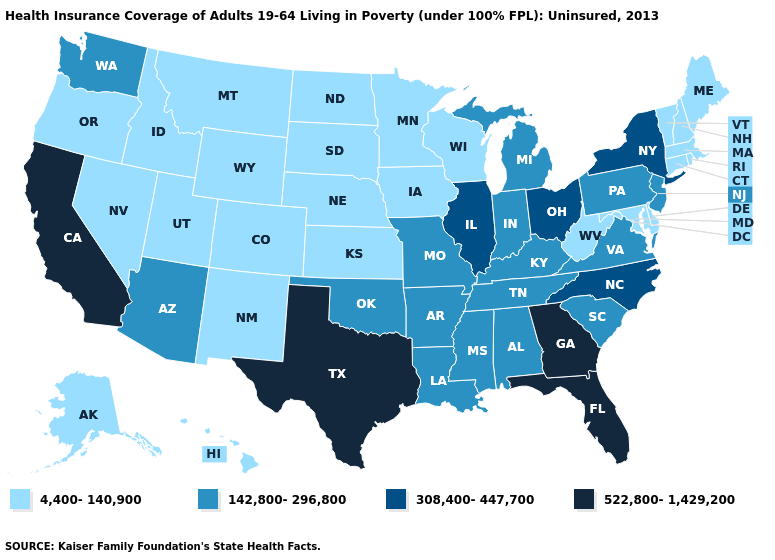What is the value of Vermont?
Concise answer only. 4,400-140,900. Name the states that have a value in the range 308,400-447,700?
Quick response, please. Illinois, New York, North Carolina, Ohio. Among the states that border Utah , which have the lowest value?
Concise answer only. Colorado, Idaho, Nevada, New Mexico, Wyoming. Does Georgia have the highest value in the USA?
Short answer required. Yes. What is the highest value in states that border South Dakota?
Short answer required. 4,400-140,900. Name the states that have a value in the range 522,800-1,429,200?
Quick response, please. California, Florida, Georgia, Texas. What is the lowest value in the USA?
Answer briefly. 4,400-140,900. Does Illinois have the same value as New Jersey?
Write a very short answer. No. Does Utah have the lowest value in the West?
Keep it brief. Yes. Does California have the highest value in the USA?
Give a very brief answer. Yes. How many symbols are there in the legend?
Concise answer only. 4. What is the value of Montana?
Answer briefly. 4,400-140,900. Which states have the lowest value in the USA?
Write a very short answer. Alaska, Colorado, Connecticut, Delaware, Hawaii, Idaho, Iowa, Kansas, Maine, Maryland, Massachusetts, Minnesota, Montana, Nebraska, Nevada, New Hampshire, New Mexico, North Dakota, Oregon, Rhode Island, South Dakota, Utah, Vermont, West Virginia, Wisconsin, Wyoming. What is the lowest value in the Northeast?
Be succinct. 4,400-140,900. 